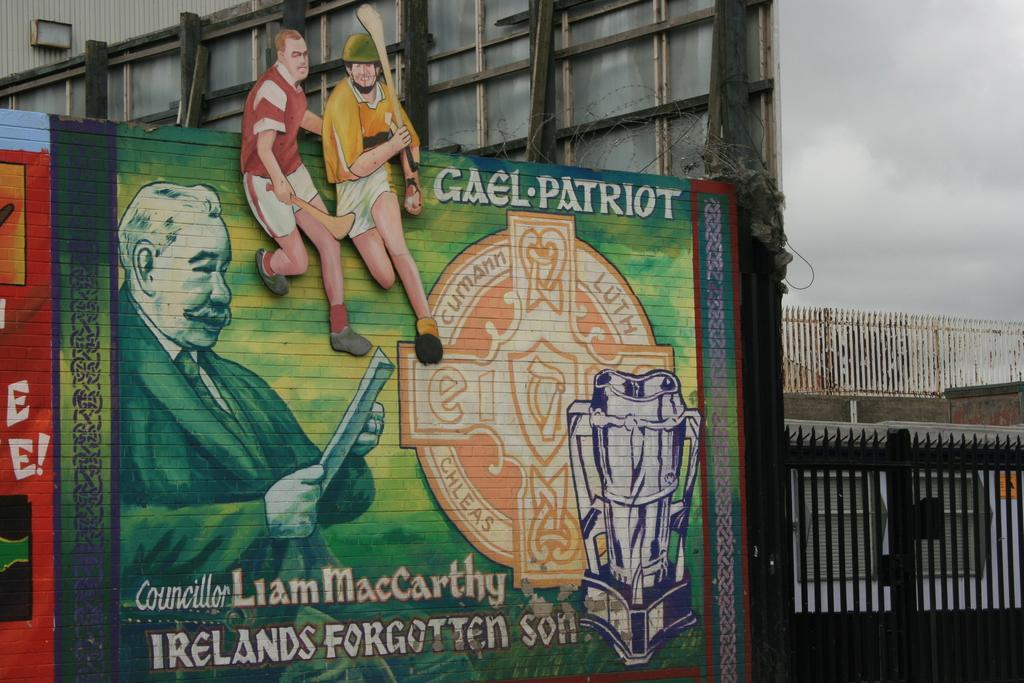<image>
Describe the image concisely. a green sign with the word Irelands on it 